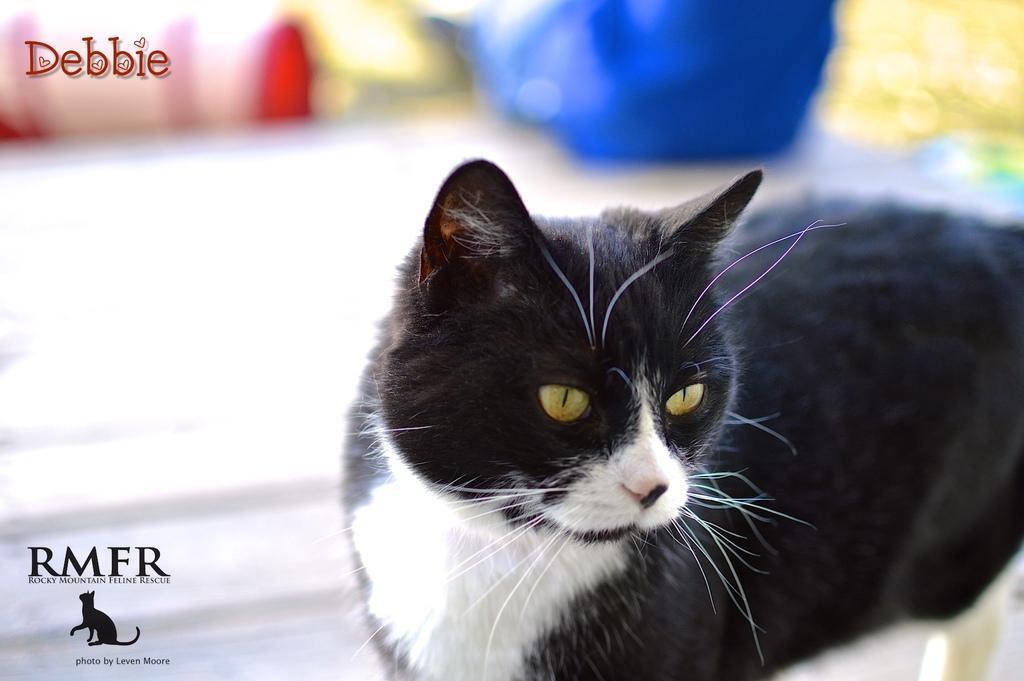Could you give a brief overview of what you see in this image? In this image, I can see a black and white cat. There is a blurred background. At the top left and the bottom left side of the image, there are watermarks and a logo. 